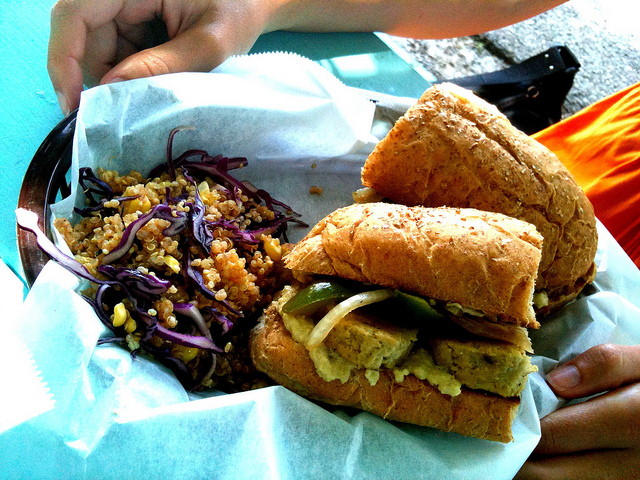What ingredients could be in the sandwich shown? The sandwich in the image seems to be filled with layers of green vegetables, possibly cucumbers or zucchini, which are great for adding crunch and flavor. There might also be a spread or hummus, and potentially a plant-based patty, judging by the texture and color visible in the image. The bread looks hearty and may be a whole grain variety, contributing to the meal's fiber content. 